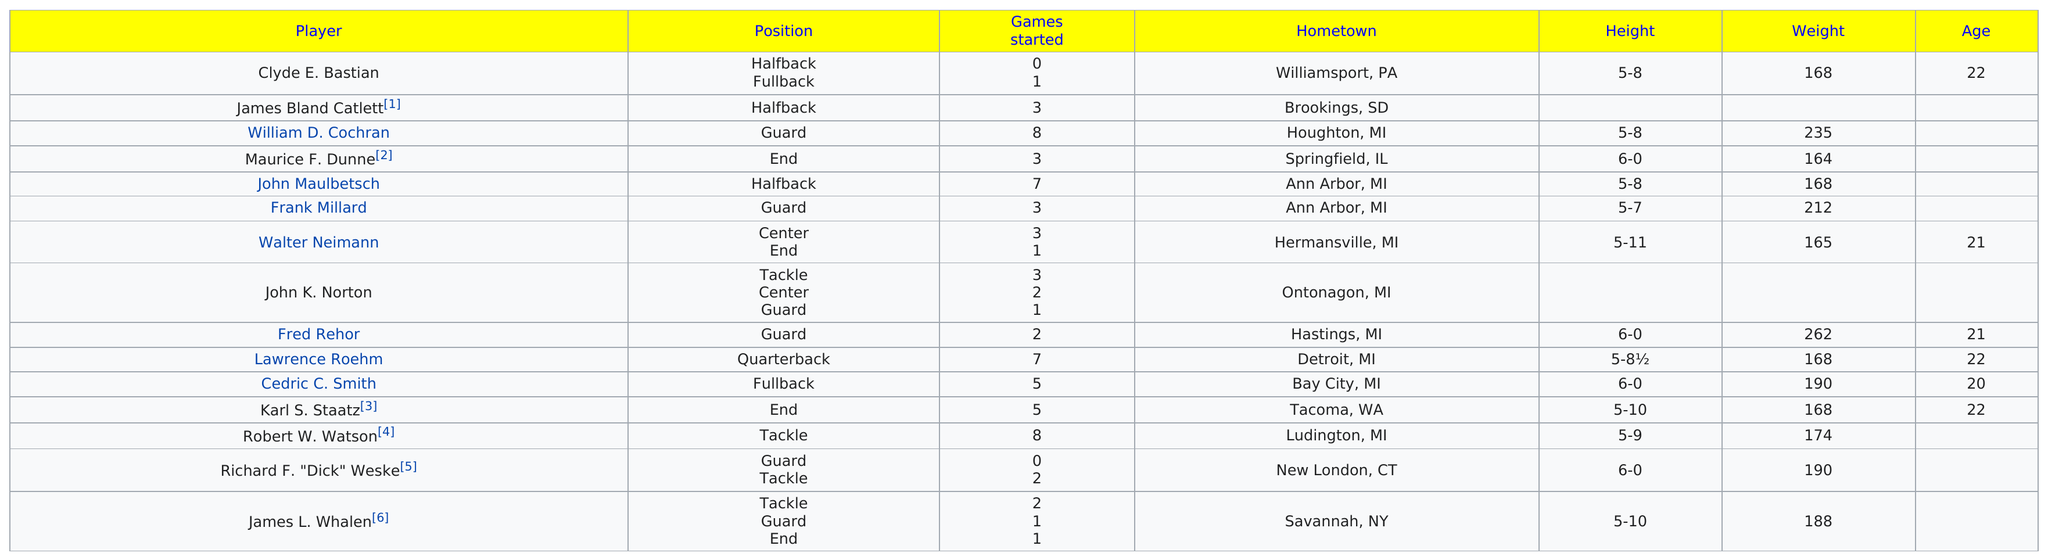List a handful of essential elements in this visual. James Bland Catlett and John Maulbetsch played the position of halfback together. Fred Rehor was the player on the letter winners roster who weighed the most. Cedric C. Smith was the tallest fullback of all time. Out of all the players present, two were from the city of Ann Arbor. Robert W. Watson had as many games started as William D. Cochran. 